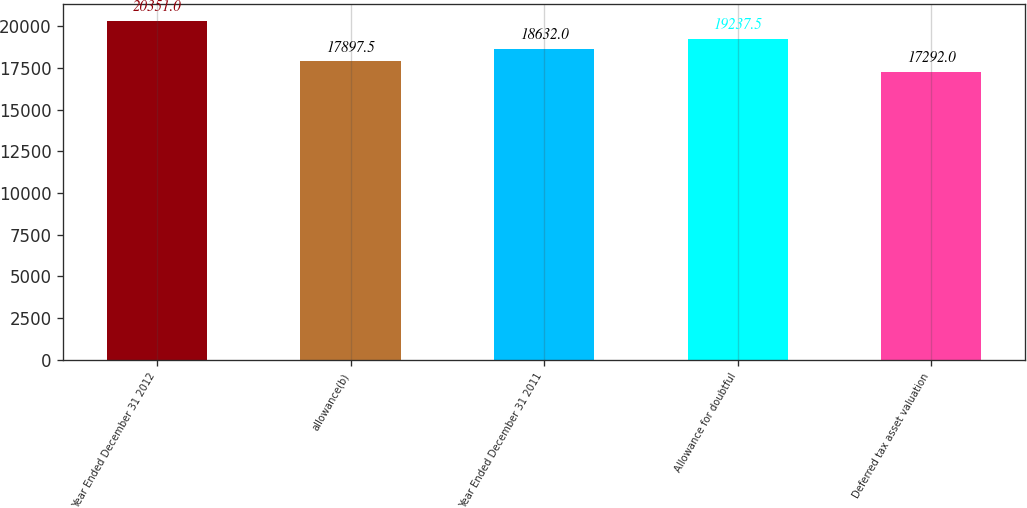Convert chart. <chart><loc_0><loc_0><loc_500><loc_500><bar_chart><fcel>Year Ended December 31 2012<fcel>allowance(b)<fcel>Year Ended December 31 2011<fcel>Allowance for doubtful<fcel>Deferred tax asset valuation<nl><fcel>20351<fcel>17897.5<fcel>18632<fcel>19237.5<fcel>17292<nl></chart> 